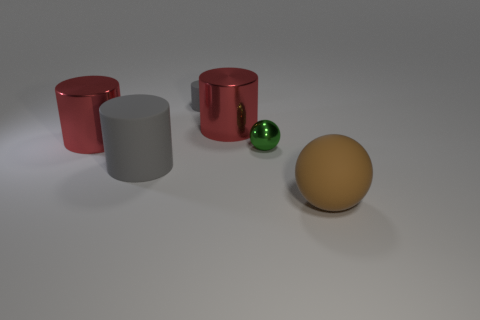Subtract all green cylinders. Subtract all green spheres. How many cylinders are left? 4 Add 3 yellow spheres. How many objects exist? 9 Subtract all balls. How many objects are left? 4 Subtract 1 red cylinders. How many objects are left? 5 Subtract all large red things. Subtract all metallic objects. How many objects are left? 1 Add 4 big balls. How many big balls are left? 5 Add 4 green rubber spheres. How many green rubber spheres exist? 4 